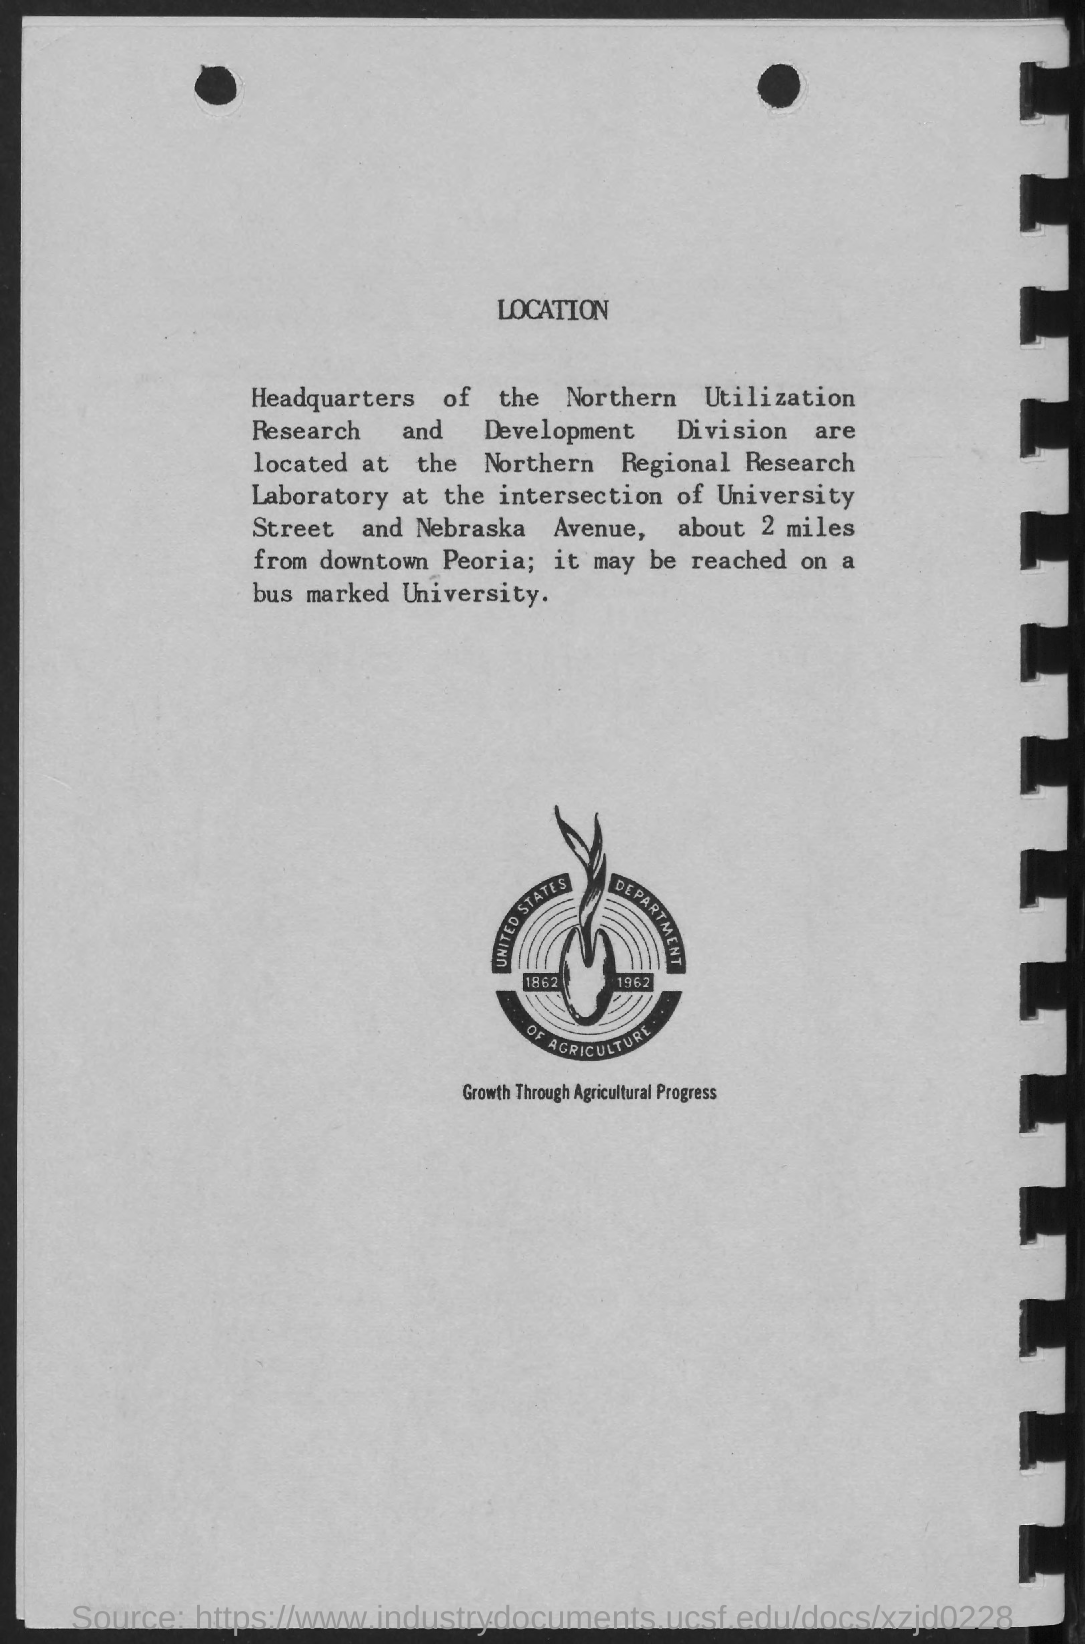What is the title of the document?
Give a very brief answer. LOCATION. What is written below the image?
Provide a short and direct response. Growth through agricultural progress. 